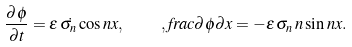<formula> <loc_0><loc_0><loc_500><loc_500>\frac { \partial \phi } { \partial t } = \epsilon \, \dot { \sigma _ { n } } \cos n x , \quad , f r a c { \partial \phi } { \partial x } = - \epsilon \, \sigma _ { n } \, n \sin n x .</formula> 